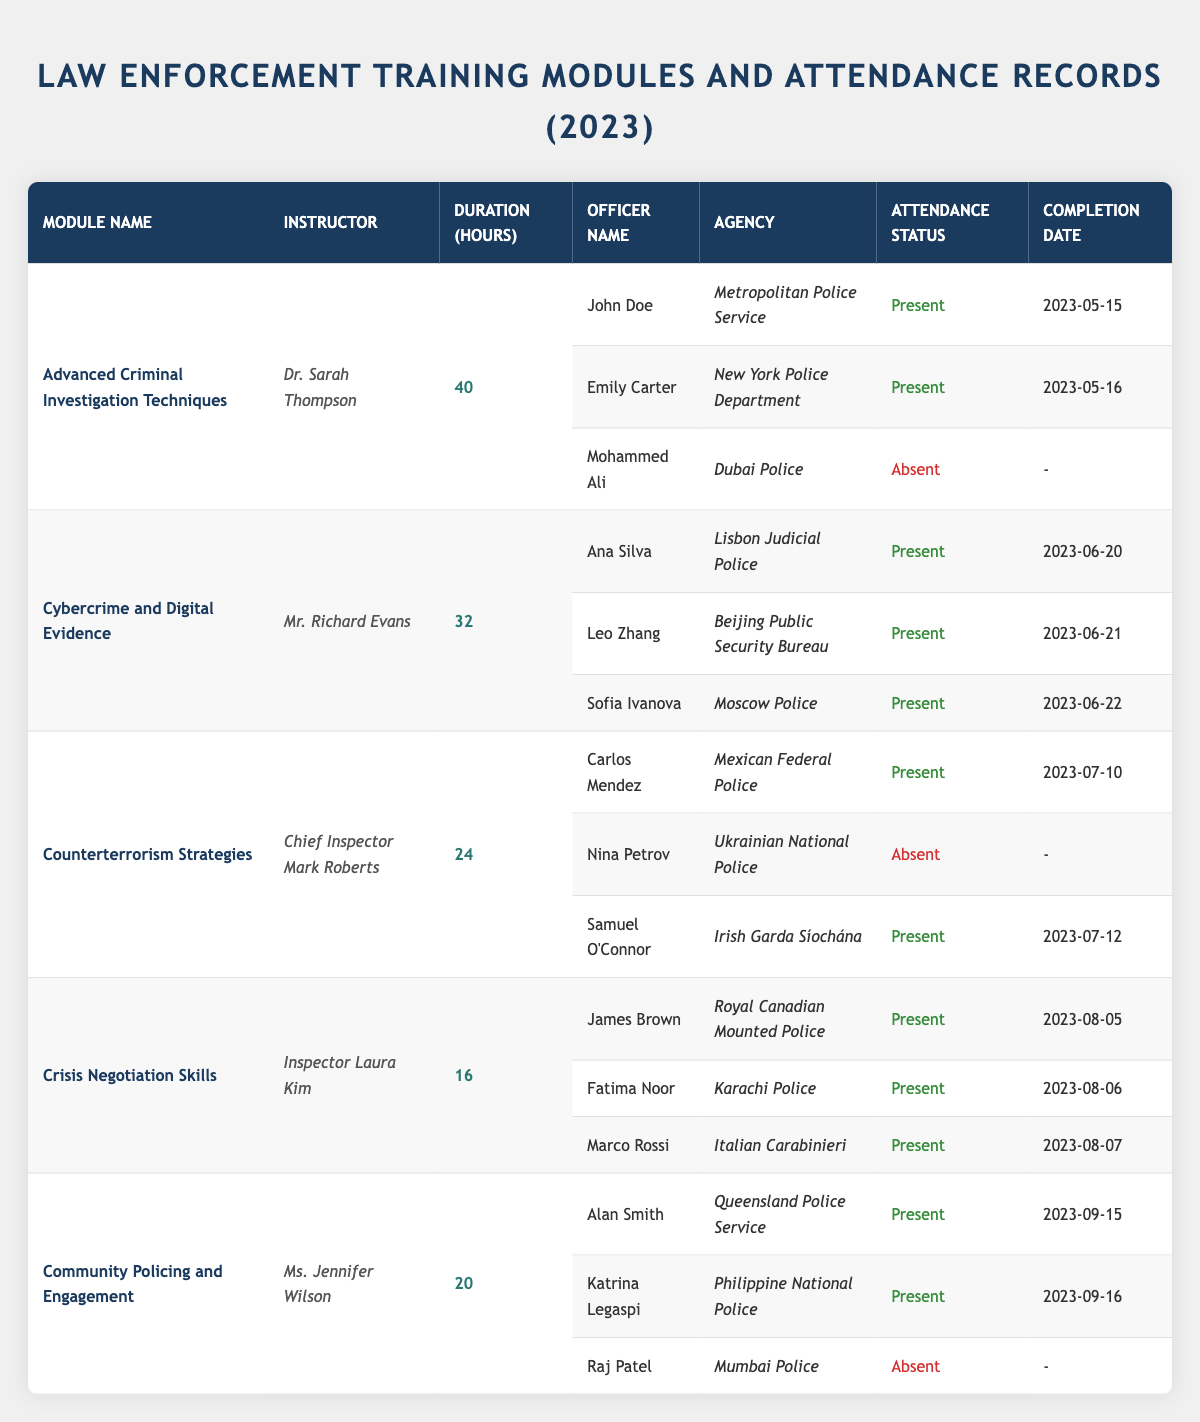What is the total number of attendance records for the "Crisis Negotiation Skills" module? There are three attendance records listed under the "Crisis Negotiation Skills" module: James Brown, Fatima Noor, and Marco Rossi.
Answer: 3 Which module had the longest duration of training hours? The "Advanced Criminal Investigation Techniques" module has the longest duration with 40 hours, as compared to the other modules.
Answer: 40 hours How many officers from Mumbai Police attended a training module? Raj Patel from Mumbai Police is listed as absent in the "Community Policing and Engagement" module, so no officers from Mumbai Police attended any training.
Answer: 0 Did all officers in the "Cybercrime and Digital Evidence" module complete the training? Yes, all recorded officers (Ana Silva, Leo Zhang, and Sofia Ivanova) from the "Cybercrime and Digital Evidence" module marked their attendance as present.
Answer: Yes What percentage of officers attended the "Counterterrorism Strategies" module? Out of three officers listed, two (Carlos Mendez and Samuel O'Connor) attended, giving an attendance rate of (2/3)*100 = 66.67%.
Answer: 66.67% Which instructor taught the module with the second highest attendance? The "Cybercrime and Digital Evidence" module had three present officers, which is the maximum attended along with others. Instructors for both highest modules are Mr. Richard Evans, but "Advanced Criminal Investigation Techniques" had only two present.
Answer: Richard Evans Who was the only officer absent in the "Community Policing and Engagement" module? Raj Patel from Mumbai Police was the only officer recorded as absent under this module.
Answer: Raj Patel How many modules had an attendance status of "Absent"? There are three instances of officers marked as absent across different modules: Mohammed Ali in "Advanced Criminal Investigation Techniques", Nina Petrov in "Counterterrorism Strategies", and Raj Patel in "Community Policing and Engagement". Totaling up these instances gives us three absences.
Answer: 3 Which module had the fewest hours of training? "Crisis Negotiation Skills" had the fewest hours with 16 hours compared to all other modules.
Answer: 16 hours Did any officers attend all sessions they registered for? Yes, officers from the "Crisis Negotiation Skills" module attended and completed all their sessions, indicating they attended all sessions.
Answer: Yes What was the completion date of the last officer who completed the training in the "Advanced Criminal Investigation Techniques" module? The last recorded completion date of an officer who attended this module is May 16, 2023, by Emily Carter.
Answer: May 16, 2023 